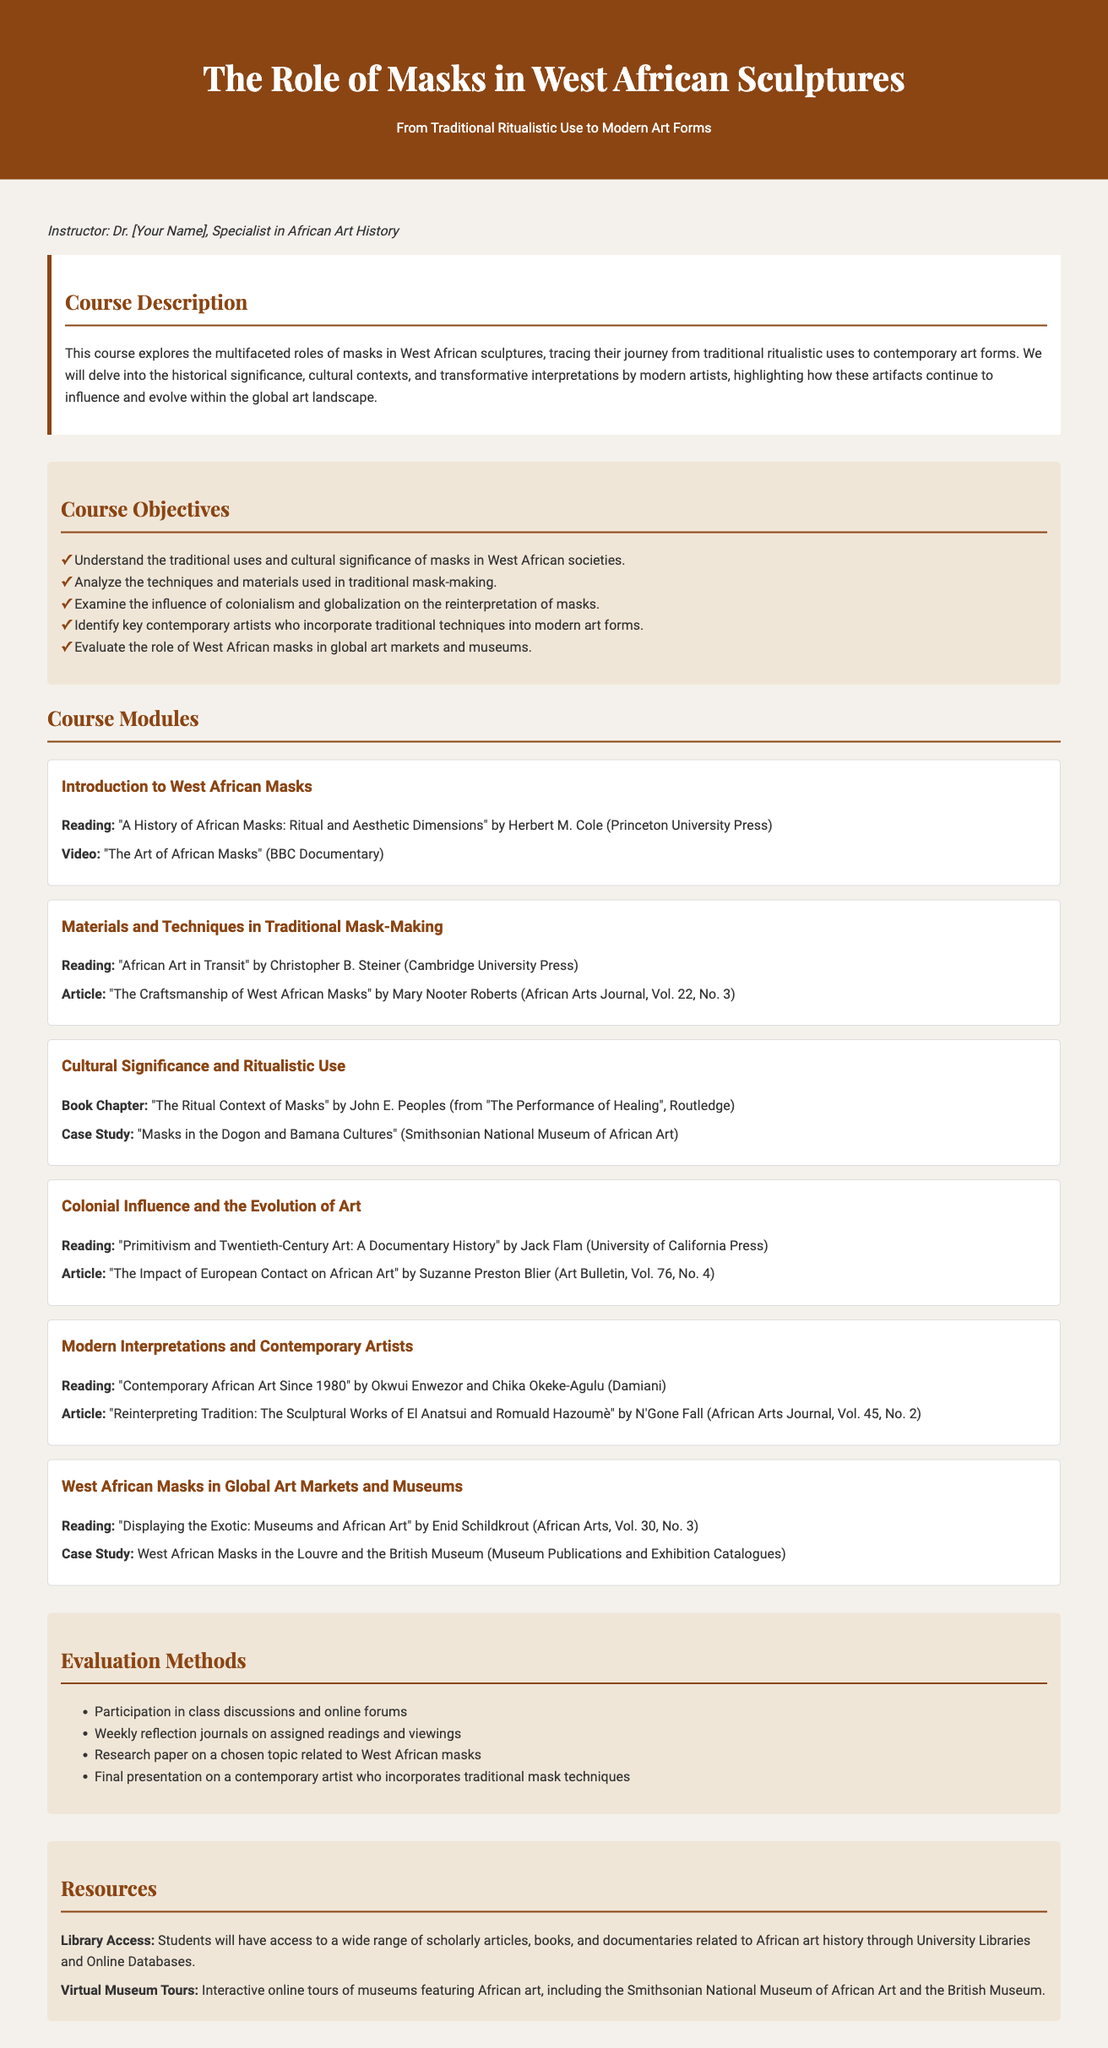What is the course title? The course title is prominently displayed in the header of the document, indicating the focus of the syllabus.
Answer: The Role of Masks in West African Sculptures Who is the instructor? The instructor's name is mentioned in the introduction section, specifying their expertise for the course.
Answer: Dr. [Your Name] What is one objective of the course? The course objectives are listed, outlining the learning goals students should aim to achieve by the end of the course.
Answer: Understand the traditional uses and cultural significance of masks in West African societies Name one reading from the module on Colonial Influence and the Evolution of Art. The readings and materials for each module are specified, providing students with a list of academic resources for study.
Answer: "Primitivism and Twentieth-Century Art: A Documentary History" by Jack Flam Which museum features a case study in the course's last module? A specific case study is highlighted, indicating a focus on the exhibition of West African masks in prominent international institutions.
Answer: British Museum How many evaluation methods are listed? The evaluation section outlines various assessment methods for the students, indicating the expectations for their performance.
Answer: Four What aspect of masks will be examined in the third module? The third module's focus is indicated, specifying what cultural elements related to masks will be explored.
Answer: Cultural Significance and Ritualistic Use What significant influence on African art is explored in this syllabus? The document discusses factors shaping the reinterpretation of African art, emphasizing external impacts on traditional practices.
Answer: Colonialism 